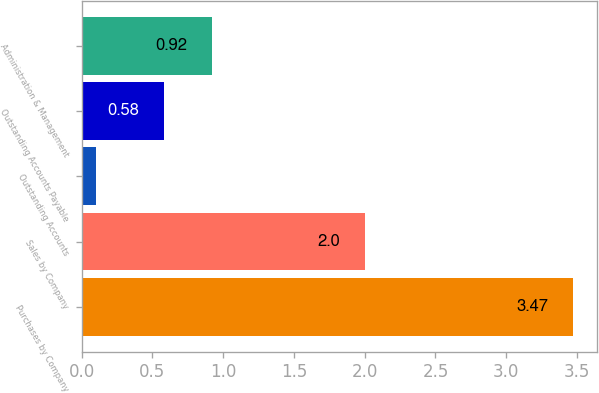<chart> <loc_0><loc_0><loc_500><loc_500><bar_chart><fcel>Purchases by Company<fcel>Sales by Company<fcel>Outstanding Accounts<fcel>Outstanding Accounts Payable<fcel>Administration & Management<nl><fcel>3.47<fcel>2<fcel>0.1<fcel>0.58<fcel>0.92<nl></chart> 